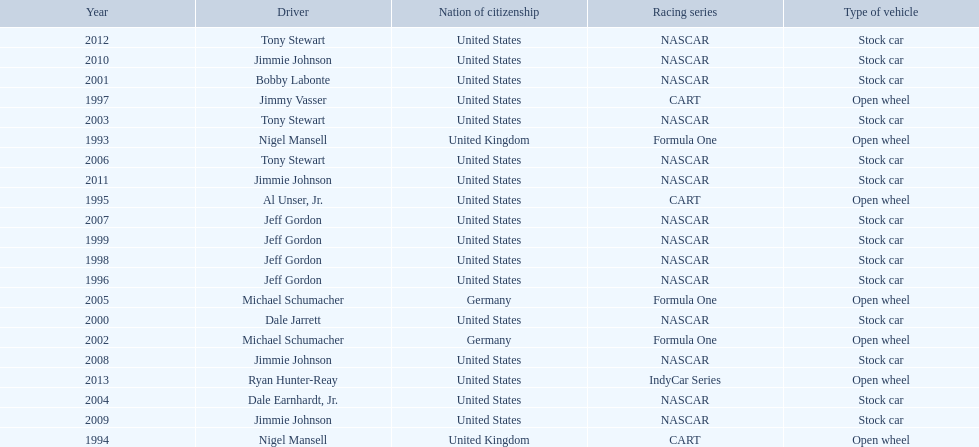Out of these drivers: nigel mansell, al unser, jr., michael schumacher, and jeff gordon, all but one has more than one espy award. who only has one espy award? Al Unser, Jr. 